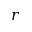<formula> <loc_0><loc_0><loc_500><loc_500>r</formula> 